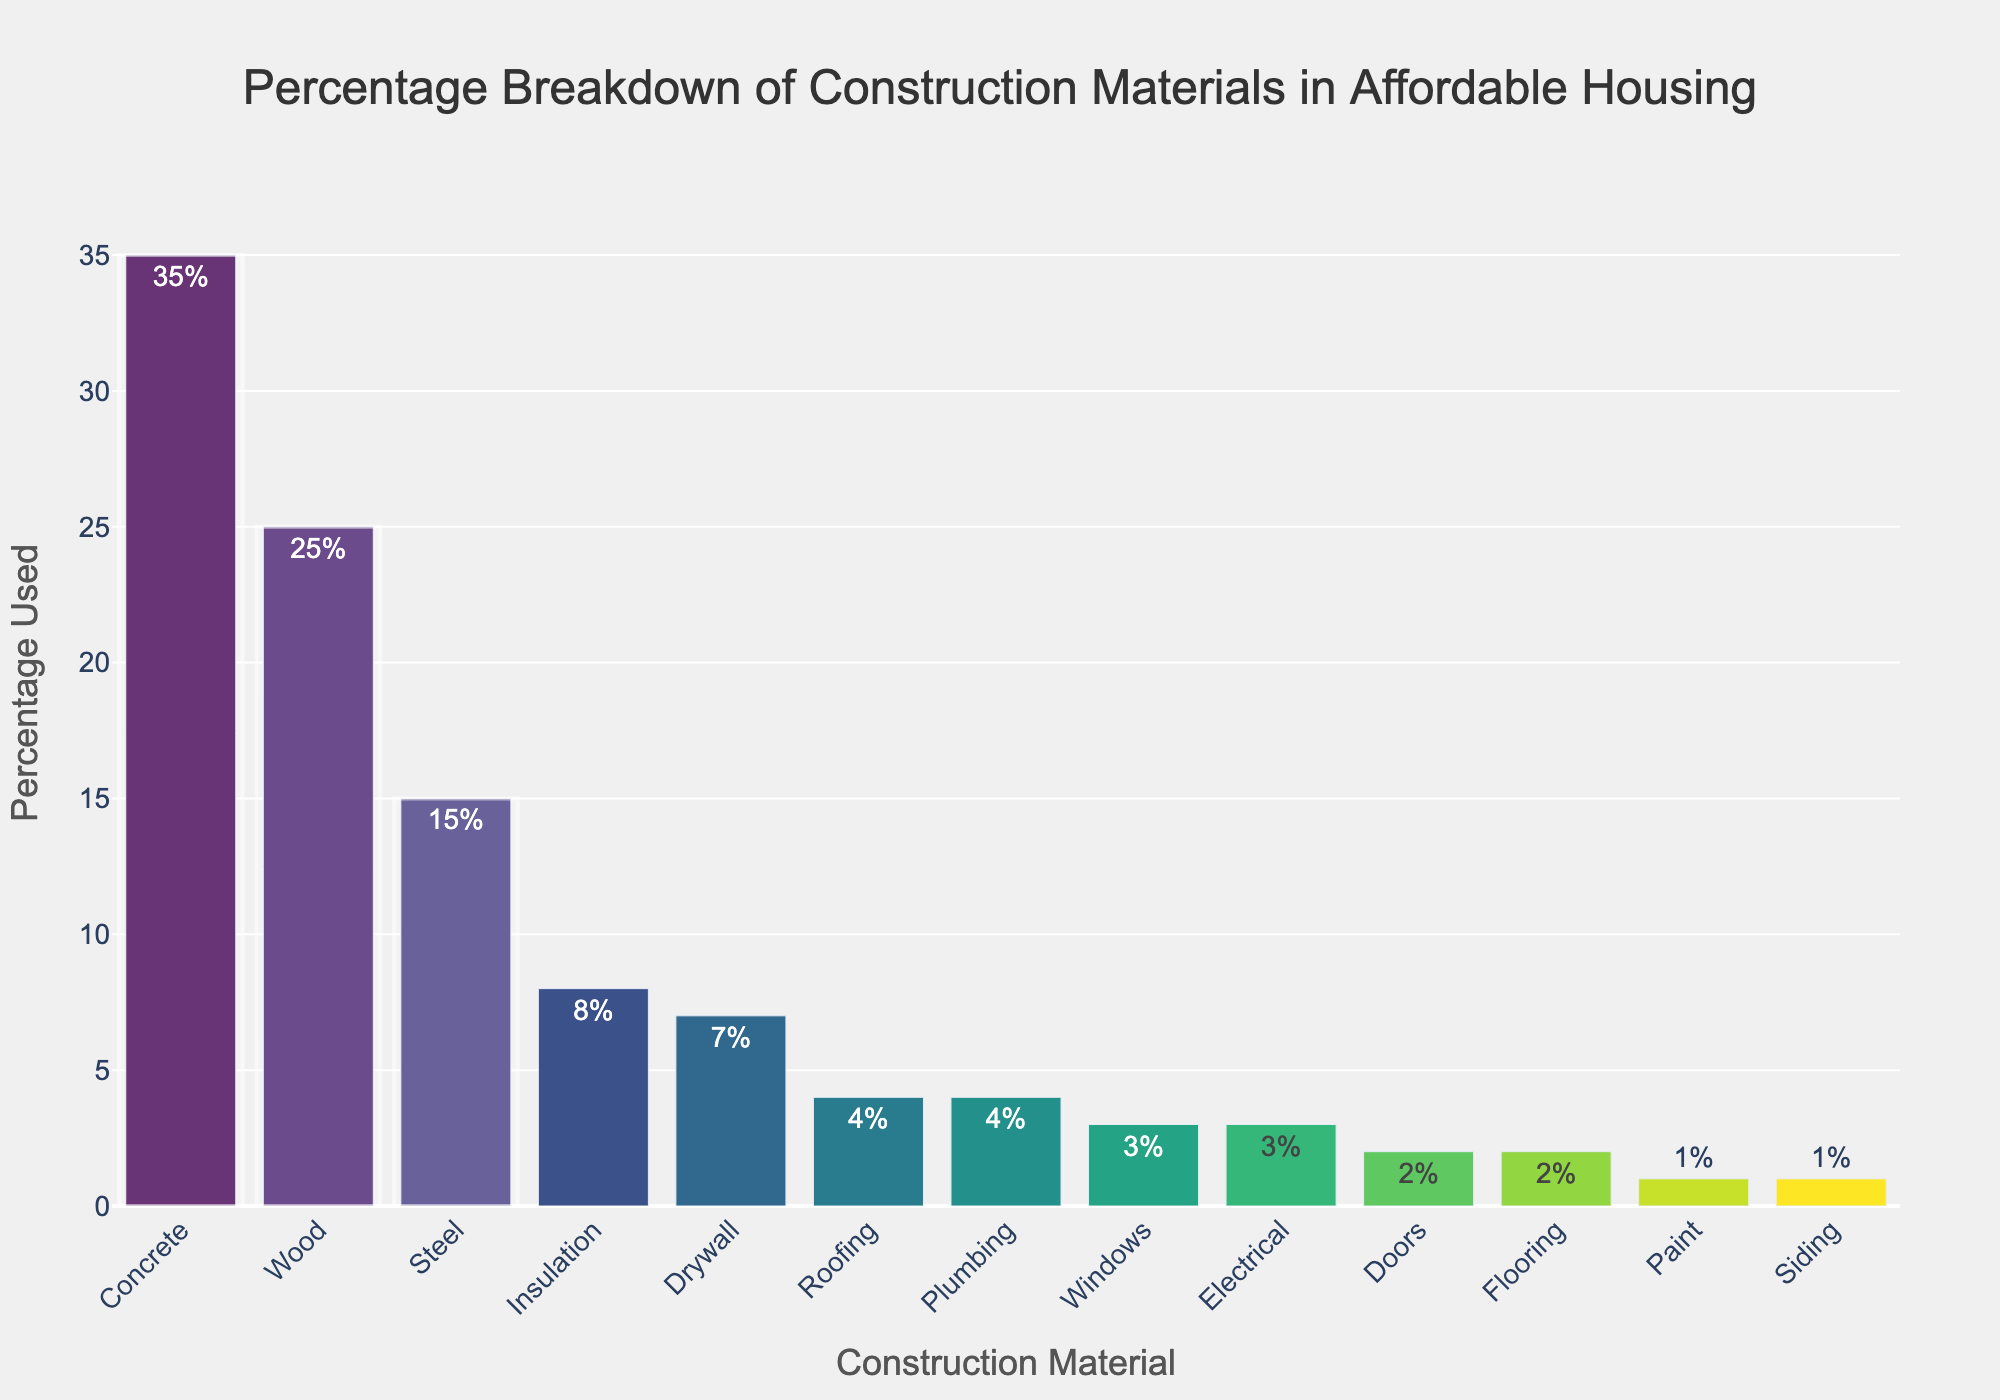What are the top three construction materials used in affordable housing? The top three materials are the ones with the highest percentages in the chart. Referring to the figure, Concrete (35%), Wood (25%), and Steel (15%) are the top three materials.
Answer: Concrete, Wood, Steel Which material is used the least and what is its percentage? The least used material will have the smallest bar and percentage value in the chart. Paint and Siding both have the smallest bars with 1% each.
Answer: Paint, Siding (1%) How many materials are used more than 10%? To find how many materials have a percentage greater than 10%, look at the bars that exceed the 10% mark on the y-axis. Concrete (35%), Wood (25%), and Steel (15%) are above 10%.
Answer: 3 materials What is the combined percentage of Windows, Doors, and Flooring? Add the percentages of Windows (3%), Doors (2%), and Flooring (2%). 3% + 2% + 2% = 7%.
Answer: 7% Is the percentage of Insulation greater than Plumbing and Electrical combined? Compare the percentage of Insulation (8%) to the sum of Plumbing (4%) and Electrical (3%), which is 7%. 8% is greater than 7%.
Answer: Yes What is the percentage difference between the most and least used materials? Subtract the percentage of the least used materials (1% for Paint and Siding) from the most used one (Concrete at 35%). 35% - 1% = 34%.
Answer: 34% How does the percentage of Drywall compare to Roofing? Compare the percentages of Drywall (7%) and Roofing (4%). Drywall (7%) is greater than Roofing (4%).
Answer: Drywall is greater Which materials have a percentage equal to or less than 5%? Identify bars with percentages equal to or less than 5%: Roofing (4%), Windows (3%), Electrical (3%), Doors (2%), Flooring (2%), Paint (1%), Siding (1%).
Answer: 7 materials 